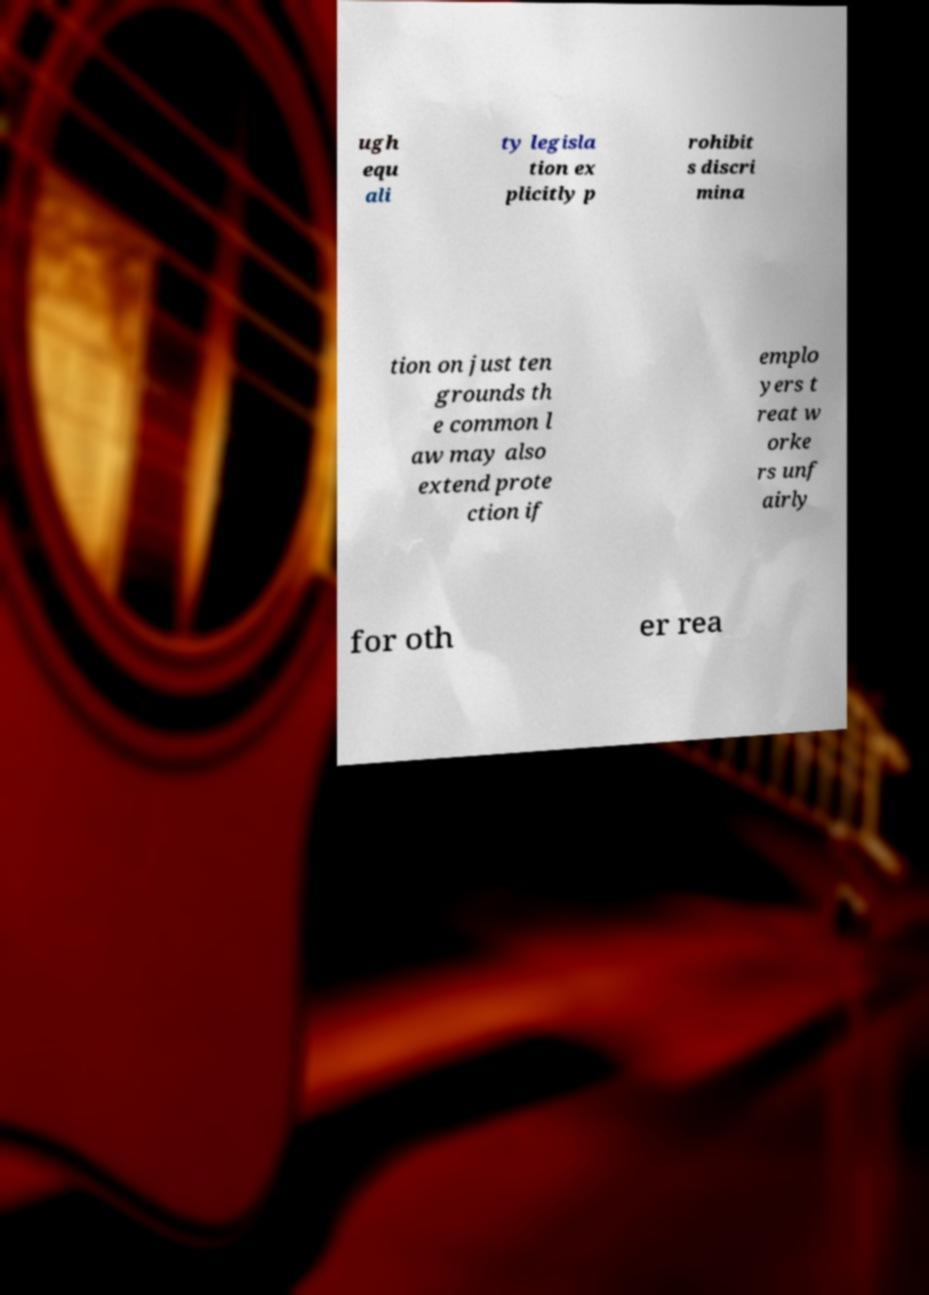Please read and relay the text visible in this image. What does it say? ugh equ ali ty legisla tion ex plicitly p rohibit s discri mina tion on just ten grounds th e common l aw may also extend prote ction if emplo yers t reat w orke rs unf airly for oth er rea 